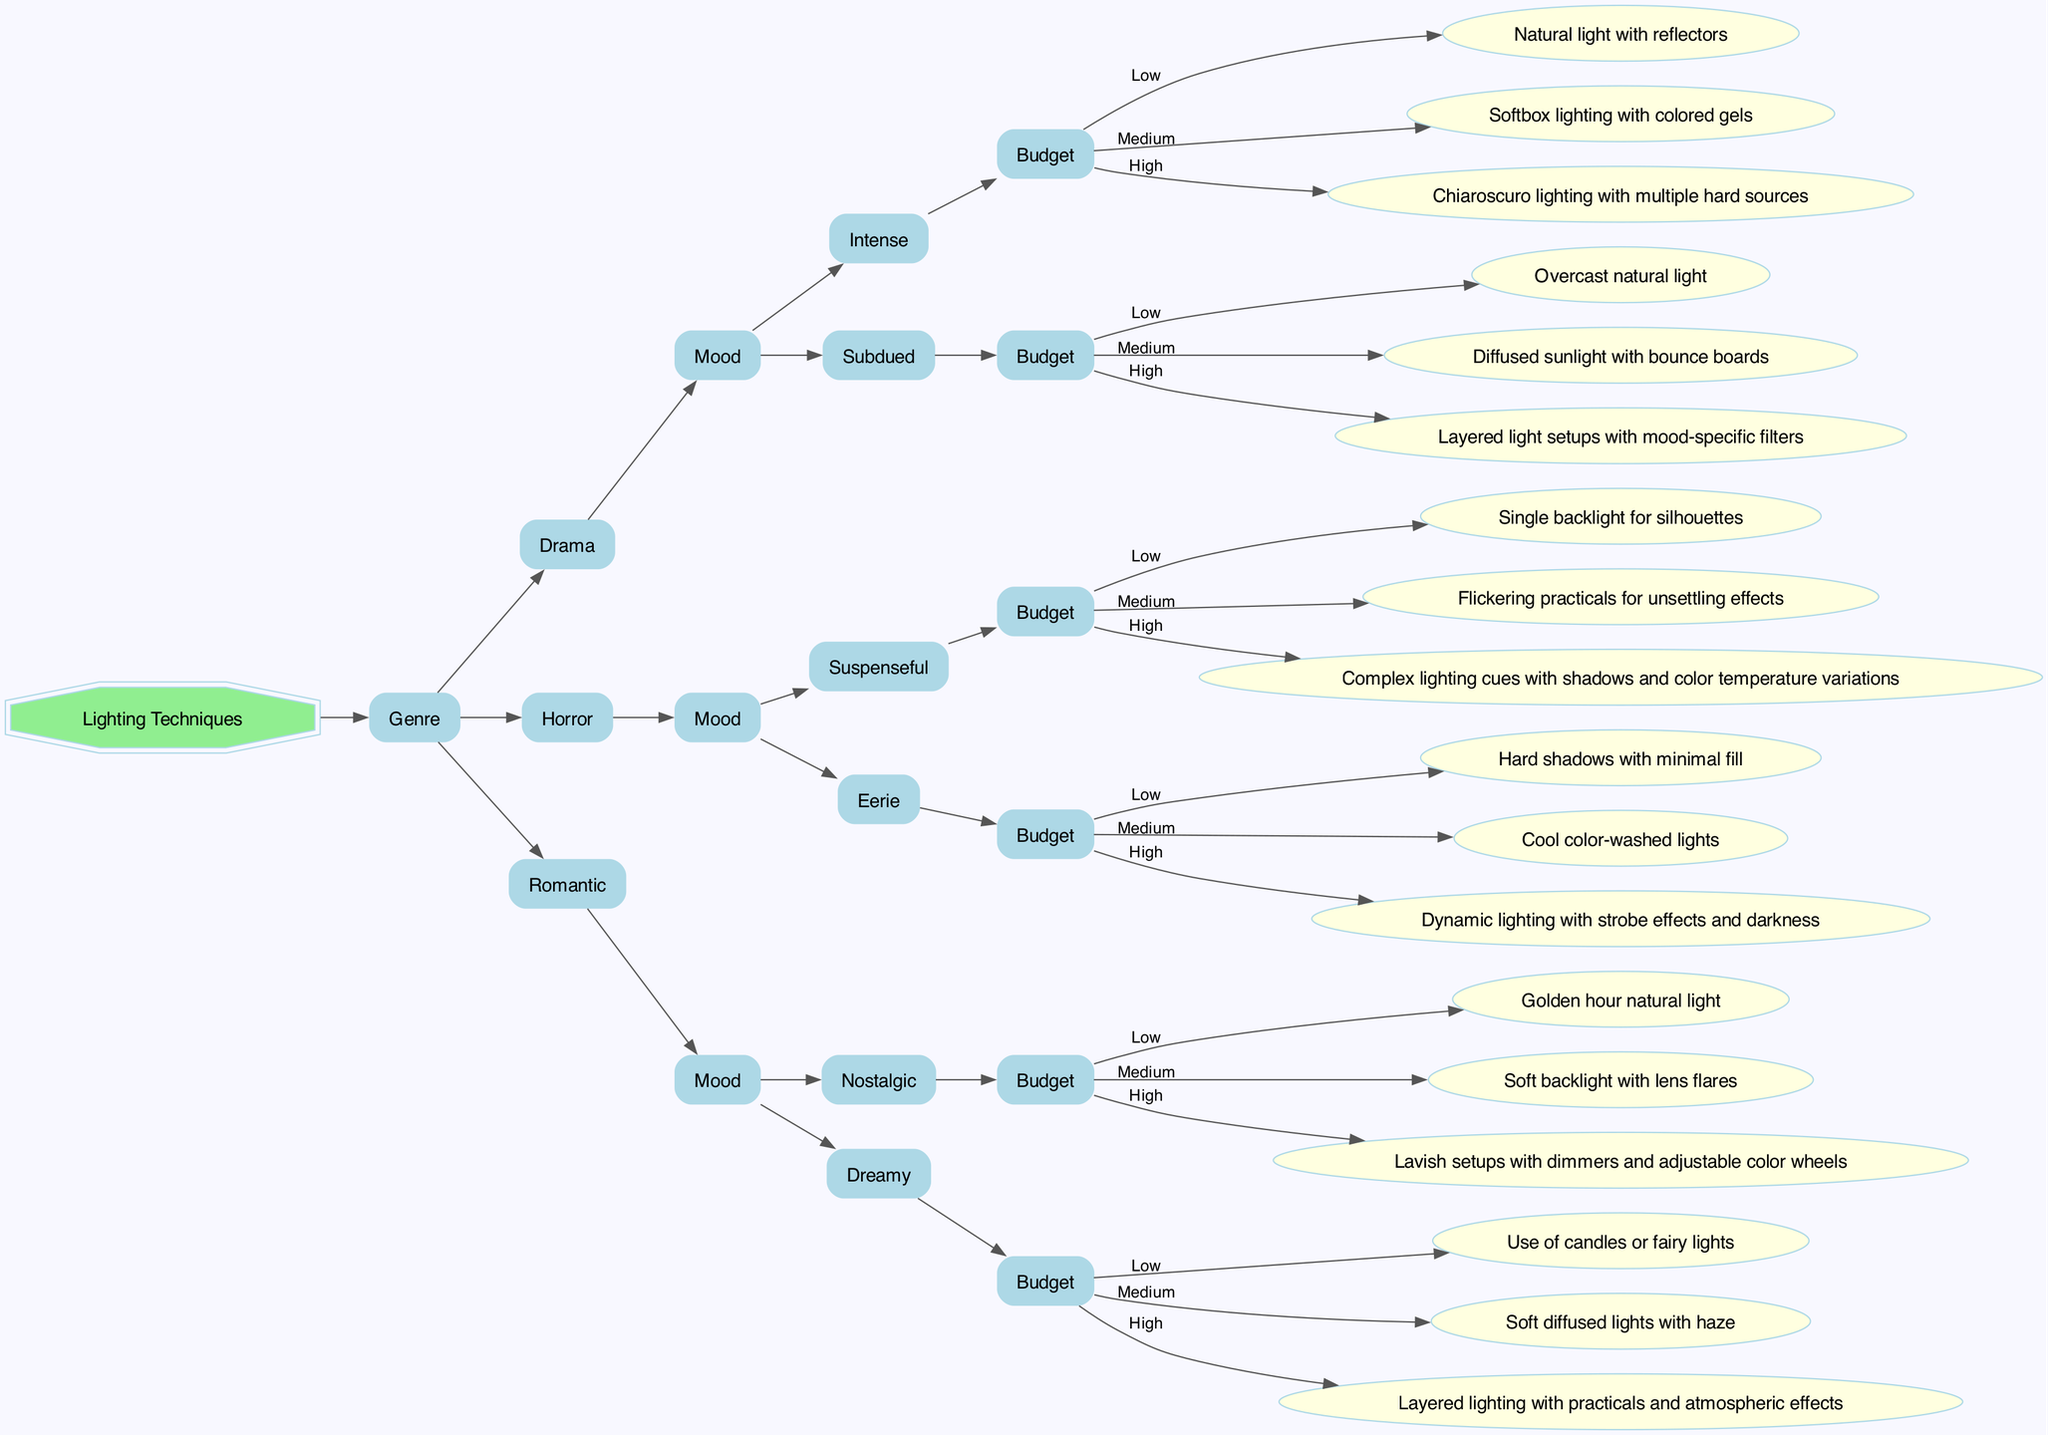What is the lighting technique for an intense mood in a drama with a low budget? The decision tree indicates that for a "Drama" with an "Intense" mood and a "Low" budget, the suggested lighting technique is "Natural light with reflectors."
Answer: Natural light with reflectors How many moods are listed under the horror genre? In the decision tree, the "Horror" genre includes two moods: "Suspenseful" and "Eerie." Therefore, there are a total of two moods listed.
Answer: 2 What is the medium budget lighting for a romantic scene that evokes a nostalgic mood? According to the diagram, for a "Romantic" scene with a "Nostalgic" mood, the medium budget lighting technique is "Soft backlight with lens flares."
Answer: Soft backlight with lens flares Which type of lighting is suggested for a low budget eerie mood in horror? For the "Horror" genre and "Eerie" mood at a "Low" budget, the diagram suggests using "Hard shadows with minimal fill."
Answer: Hard shadows with minimal fill What is the budget category for the highest complexity lighting in a suspenseful horror scene? The decision tree specifies that for a "Suspenseful" mood in the "Horror" genre at a "High" budget, the recommended lighting is "Complex lighting cues with shadows and color temperature variations." Thus, the highest complexity falls under the "High" budget category.
Answer: High What are the number of different lighting techniques available for a romantic dreamy scene at a medium budget? In the diagram, for a "Romantic" scene and "Dreamy" mood at a "Medium" budget, the suggested lighting technique is "Soft diffused lights with haze," indicating that there is one specific lighting technique available in this case.
Answer: 1 Which lighting technique would apply if the genre is horror, the mood is suspenseful, and the budget is medium? The decision tree indicates that for the "Horror" genre, with a "Suspenseful" mood, and a "Medium" budget, the lighting technique recommended is "Flickering practicals for unsettling effects."
Answer: Flickering practicals for unsettling effects What is the total number of unique lighting techniques displayed for romantic scenes? The diagram lists two moods for the "Romantic" genre: "Nostalgic" and "Dreamy," with each mood having three different lighting techniques. Therefore, the total number of unique techniques is 6.
Answer: 6 